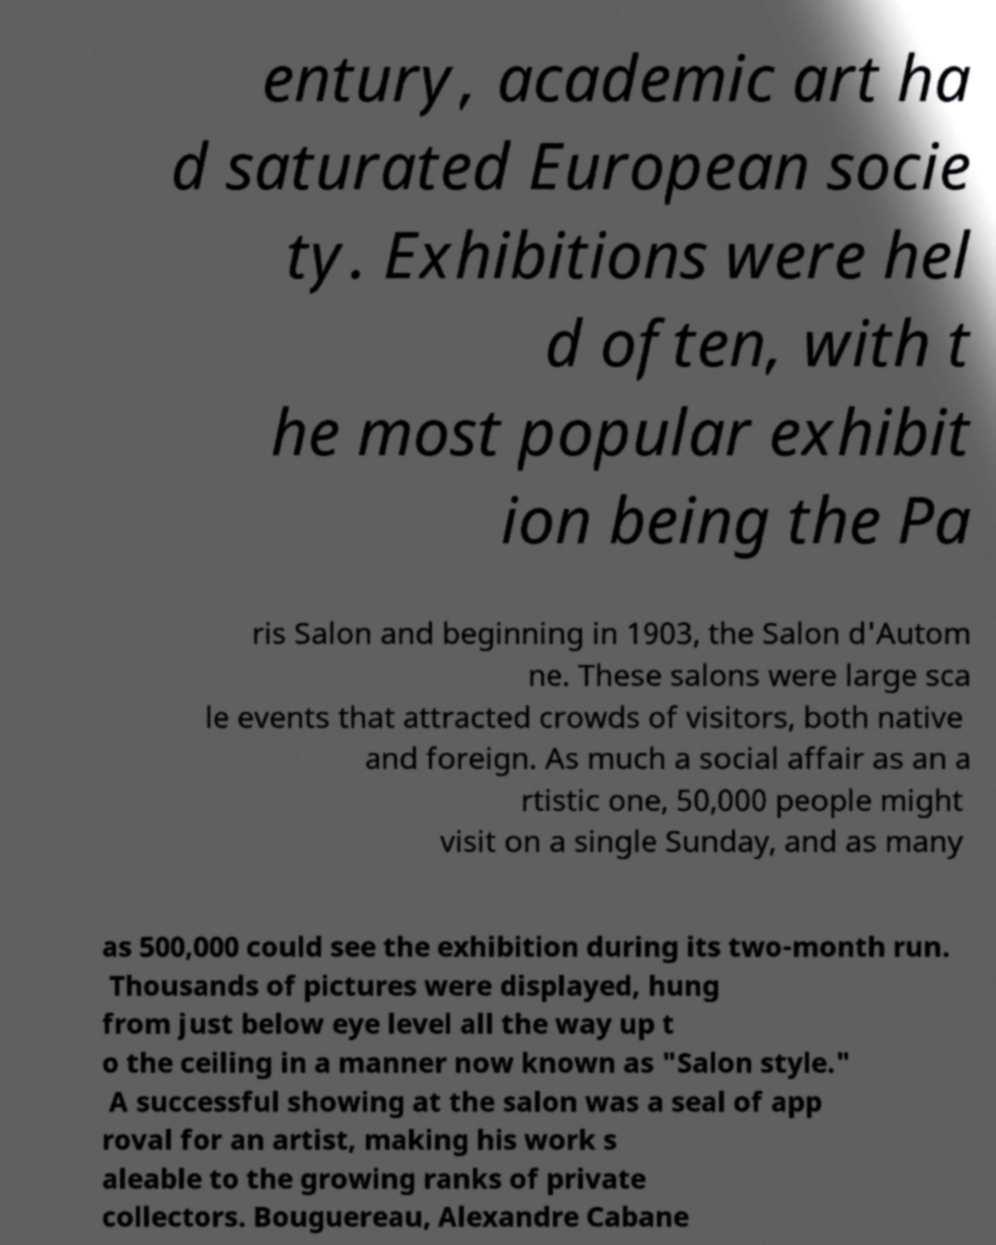There's text embedded in this image that I need extracted. Can you transcribe it verbatim? entury, academic art ha d saturated European socie ty. Exhibitions were hel d often, with t he most popular exhibit ion being the Pa ris Salon and beginning in 1903, the Salon d'Autom ne. These salons were large sca le events that attracted crowds of visitors, both native and foreign. As much a social affair as an a rtistic one, 50,000 people might visit on a single Sunday, and as many as 500,000 could see the exhibition during its two-month run. Thousands of pictures were displayed, hung from just below eye level all the way up t o the ceiling in a manner now known as "Salon style." A successful showing at the salon was a seal of app roval for an artist, making his work s aleable to the growing ranks of private collectors. Bouguereau, Alexandre Cabane 